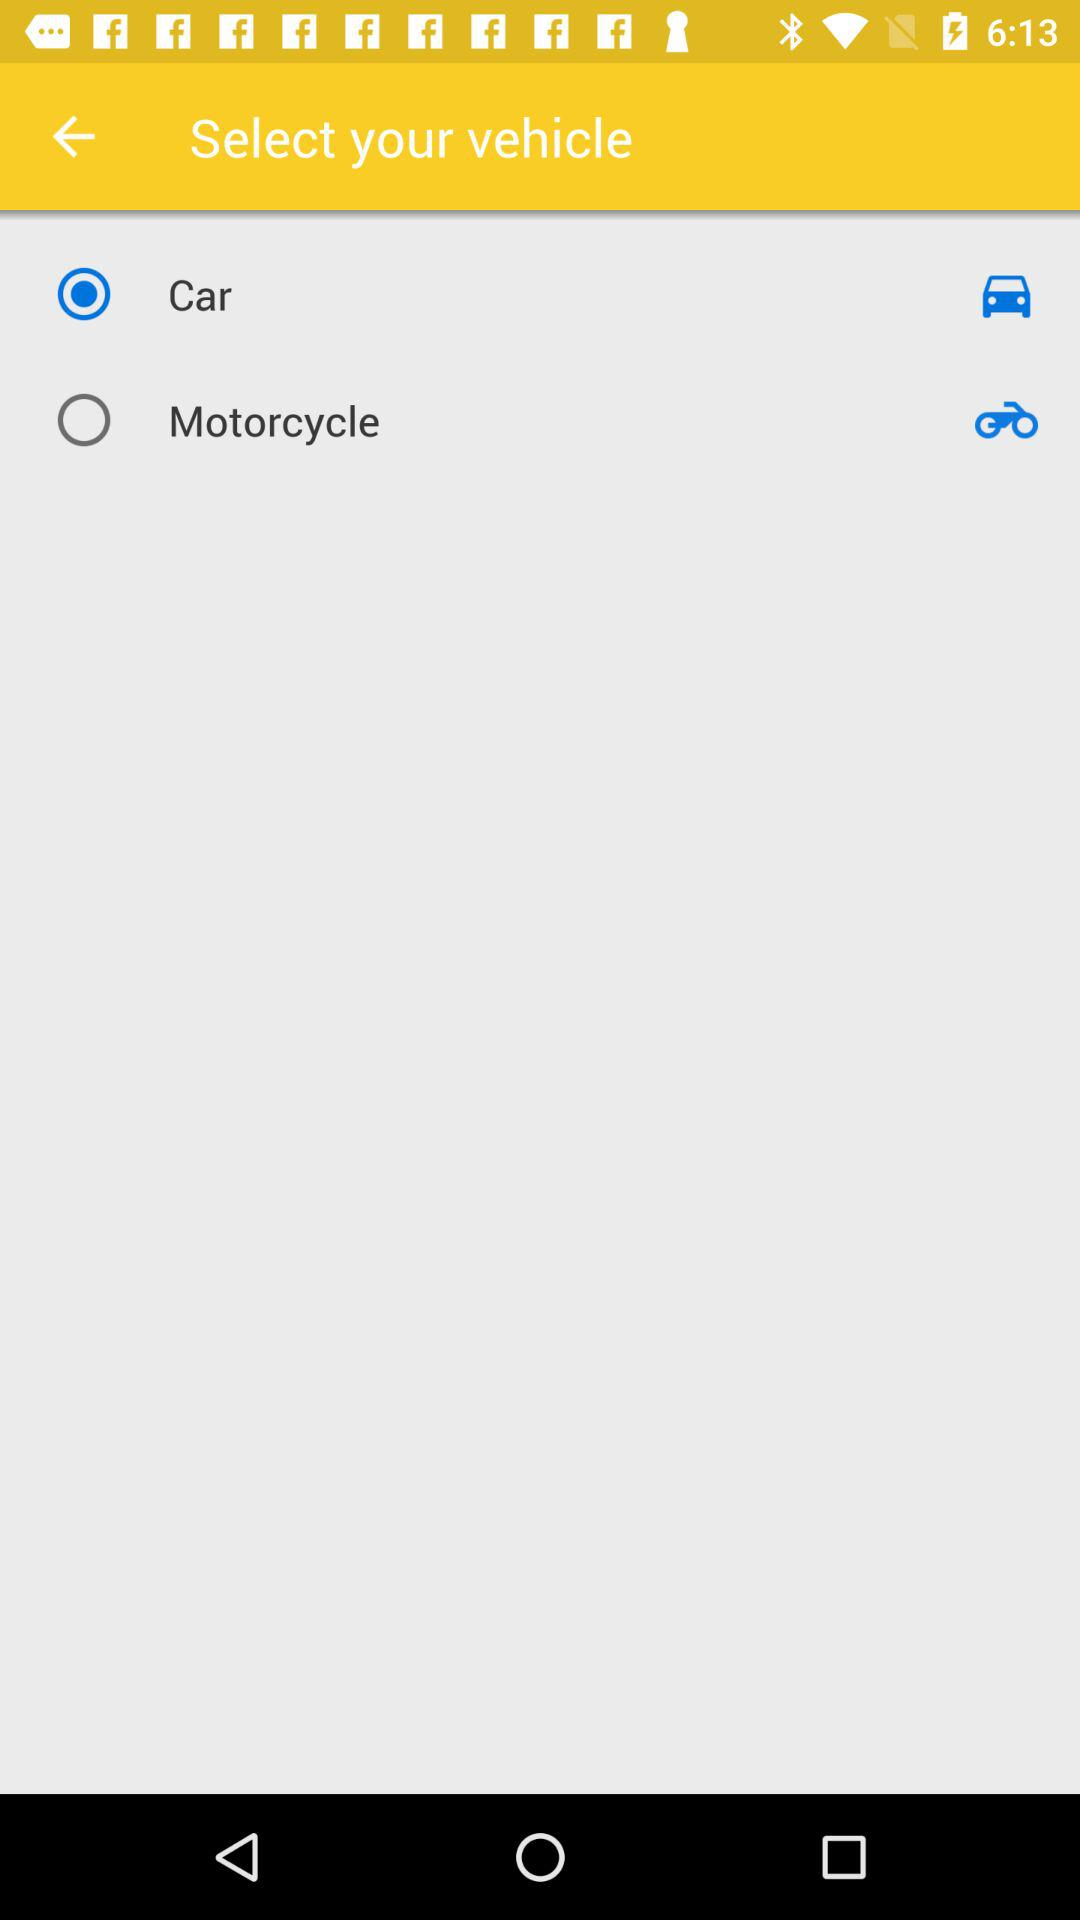Which is the selected vehicle? The selected vehicle is "Car". 